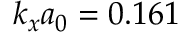Convert formula to latex. <formula><loc_0><loc_0><loc_500><loc_500>k _ { x } a _ { 0 } = 0 . 1 6 1</formula> 